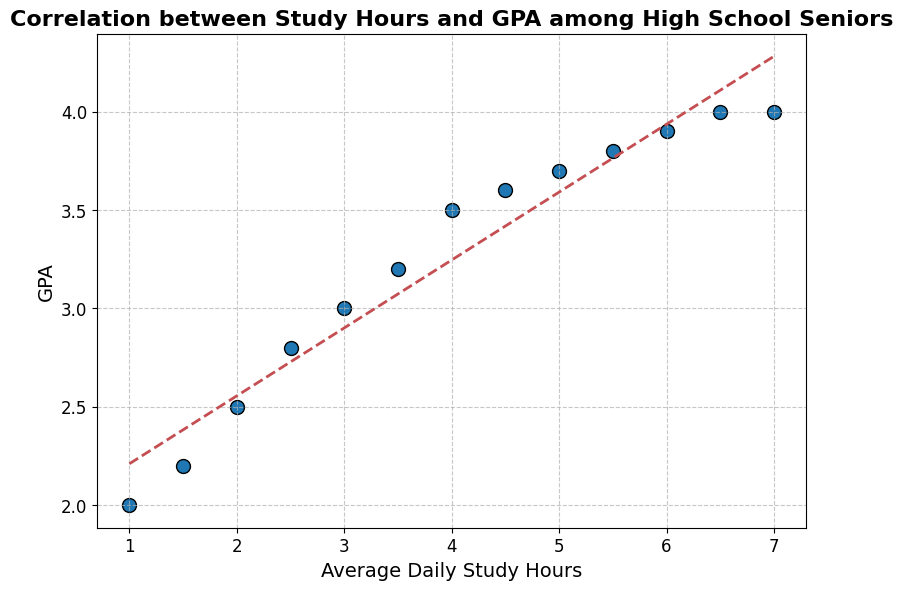What's the average GPA for students who study 4.0 hours and above? To find the average GPA for students who study 4.0 hours and above, we need to take the GPAs for study hours of 4.0, 4.5, 5.0, 5.5, 6.0, 6.5, and 7.0: (3.5 + 3.6 + 3.7 + 3.8 + 3.9 + 4.0 + 4.0) / 7. The sum of these GPAs is 26.5, so the average is 26.5 / 7 which is approximately 3.79.
Answer: 3.79 Which study hour interval shows the steepest increase in GPA? We look for the largest increase in GPA by comparing increments between consecutive points. The steepest increase is between 3.5 hours (GPA 3.2) and 4.0 hours (GPA 3.5), where the GPA increases by 0.3 points.
Answer: 3.5 to 4.0 hours What is the GPA for the student studying 1 hour? According to the plot, the GPA corresponding to 1 hour of study is directly read from the graph. The GPA is 2.0.
Answer: 2.0 Does the trendline on the plot indicate a positive or negative correlation between study hours and GPA? Observing the direction of the trendline, it slopes upwards from left to right, indicating that as study hours increase, GPA also increases, demonstrating a positive correlation.
Answer: Positive Are there any students with the same GPA despite different study hours? Yes, according to the plot, there are two study hours (6.5 and 7.0) which both have a GPA of 4.0.
Answer: Yes What's the range of GPAs for the students studying between 2.0 to 5.0 hours daily? Identifying the GPAs for students studying 2.0, 2.5, 3.0, 3.5, 4.0, and 4.5 hours, we get: 2.5, 2.8, 3.0, 3.2, 3.5, and 3.6. The highest value is 3.6 and the lowest value is 2.5. The range is 3.6 - 2.5 = 1.1.
Answer: 1.1 How does the GPA change from 1.0 hour to 7.0 hours of study? The GPA at 1.0 hour is 2.0 and at 7.0 hours is 4.0, showing an increase of 4.0 - 2.0 = 2.0 points.
Answer: 2.0 points Which data point on the plot has the highest GPA? By looking at the scatter plot, both 6.5 and 7.0 study hours have the highest GPA of 4.0.
Answer: 6.5 and 7.0 hours What color represents the data points on the plot? The scatter plot shows data points that are colored blue.
Answer: Blue 